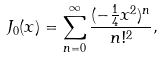Convert formula to latex. <formula><loc_0><loc_0><loc_500><loc_500>J _ { 0 } ( x ) = \sum _ { n = 0 } ^ { \infty } \frac { ( - \frac { 1 } { 4 } x ^ { 2 } ) ^ { n } } { n ! ^ { 2 } } ,</formula> 